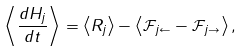<formula> <loc_0><loc_0><loc_500><loc_500>\left < \frac { d H _ { j } } { d t } \right > = \left < R _ { j } \right > - \left < \mathcal { F } _ { j \leftarrow } - \mathcal { F } _ { j \rightarrow } \right > ,</formula> 